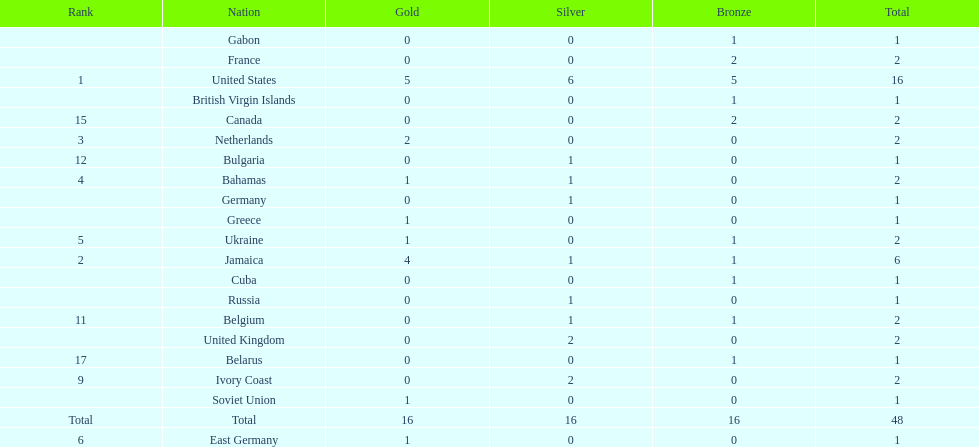Which countries won at least 3 silver medals? United States. 